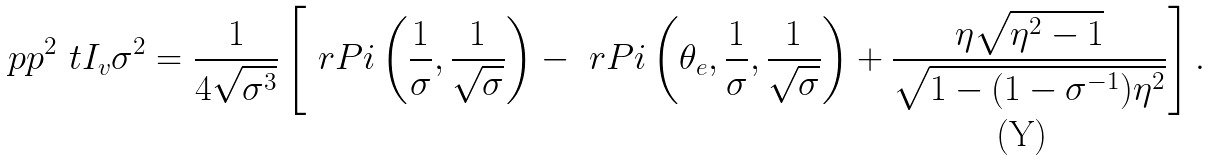Convert formula to latex. <formula><loc_0><loc_0><loc_500><loc_500>\ p p { ^ { 2 } \ t I _ { v } } { \sigma ^ { 2 } } = \frac { 1 } { 4 \sqrt { \sigma ^ { 3 } } } \left [ \ r P i \left ( \frac { 1 } { \sigma } , \frac { 1 } { \sqrt { \sigma } } \right ) - \ r P i \left ( \theta _ { e } , \frac { 1 } { \sigma } , \frac { 1 } { \sqrt { \sigma } } \right ) + \frac { \eta \sqrt { \eta ^ { 2 } - 1 } } { \sqrt { 1 - ( 1 - \sigma ^ { - 1 } ) \eta ^ { 2 } } } \right ] .</formula> 